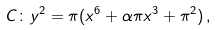Convert formula to latex. <formula><loc_0><loc_0><loc_500><loc_500>C \colon y ^ { 2 } = \pi ( x ^ { 6 } + \alpha \pi x ^ { 3 } + \pi ^ { 2 } ) \, ,</formula> 